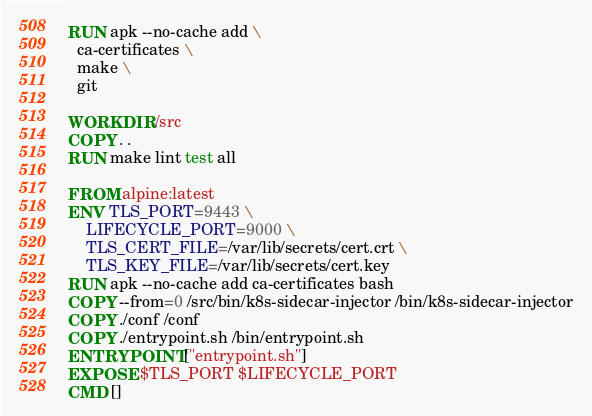<code> <loc_0><loc_0><loc_500><loc_500><_Dockerfile_>RUN apk --no-cache add \
  ca-certificates \
  make \
  git

WORKDIR /src
COPY . .
RUN make lint test all

FROM alpine:latest
ENV TLS_PORT=9443 \
    LIFECYCLE_PORT=9000 \
    TLS_CERT_FILE=/var/lib/secrets/cert.crt \
    TLS_KEY_FILE=/var/lib/secrets/cert.key
RUN apk --no-cache add ca-certificates bash
COPY --from=0 /src/bin/k8s-sidecar-injector /bin/k8s-sidecar-injector
COPY ./conf /conf
COPY ./entrypoint.sh /bin/entrypoint.sh
ENTRYPOINT ["entrypoint.sh"]
EXPOSE $TLS_PORT $LIFECYCLE_PORT
CMD []
</code> 